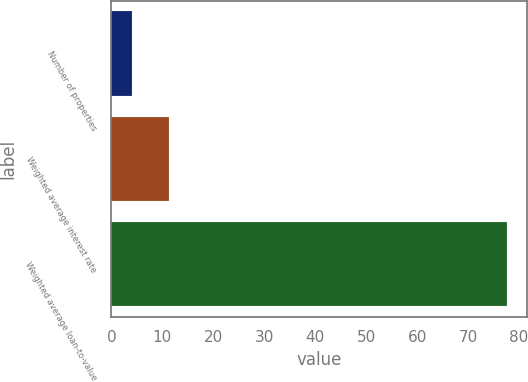Convert chart. <chart><loc_0><loc_0><loc_500><loc_500><bar_chart><fcel>Number of properties<fcel>Weighted average interest rate<fcel>Weighted average loan-to-value<nl><fcel>4<fcel>11.37<fcel>77.7<nl></chart> 